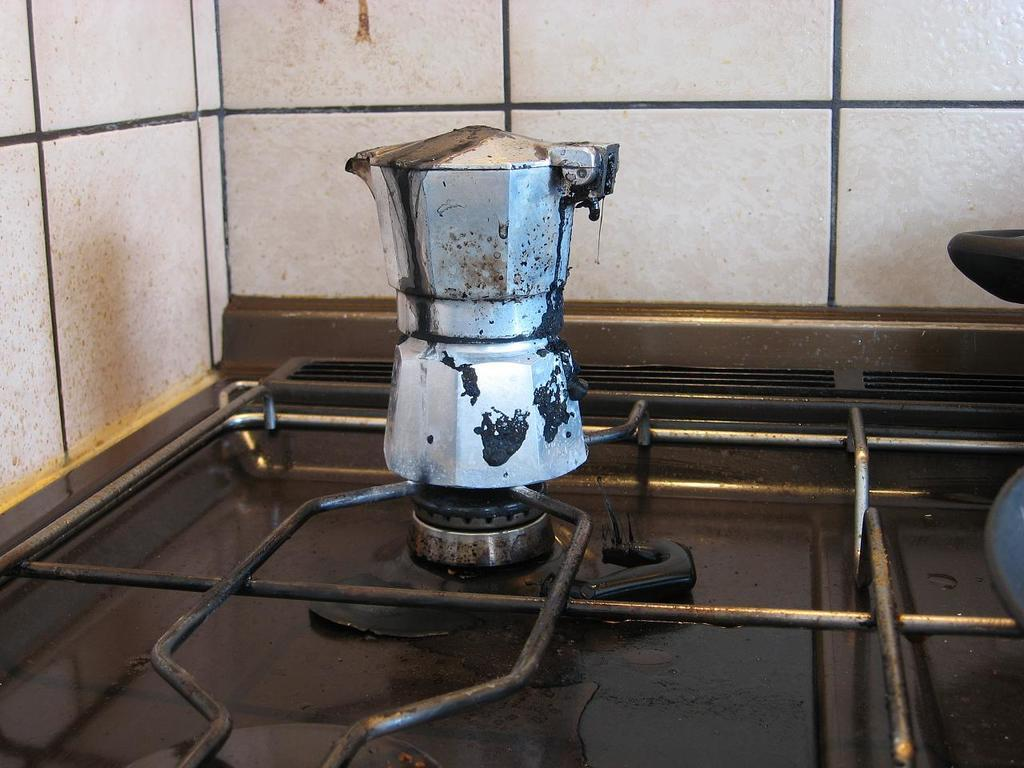What is on the stove in the image? There is a vessel on the stove in the image. What else can be seen in the image besides the vessel on the stove? There are iron rods visible in the image. What type of flooring is present in the background of the image? There are tiles in the background of the image. What type of truck is parked outside the window in the image? There is no truck visible in the image, as it only shows a vessel on the stove, iron rods, and tiles in the background. 